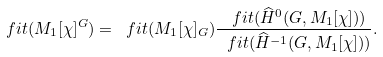Convert formula to latex. <formula><loc_0><loc_0><loc_500><loc_500>\ f i t ( M _ { 1 } [ \chi ] ^ { G } ) = \ f i t ( M _ { 1 } [ \chi ] _ { G } ) \frac { \ f i t ( \widehat { H } ^ { 0 } ( G , M _ { 1 } [ \chi ] ) ) } { \ f i t ( \widehat { H } ^ { - 1 } ( G , M _ { 1 } [ \chi ] ) ) } .</formula> 